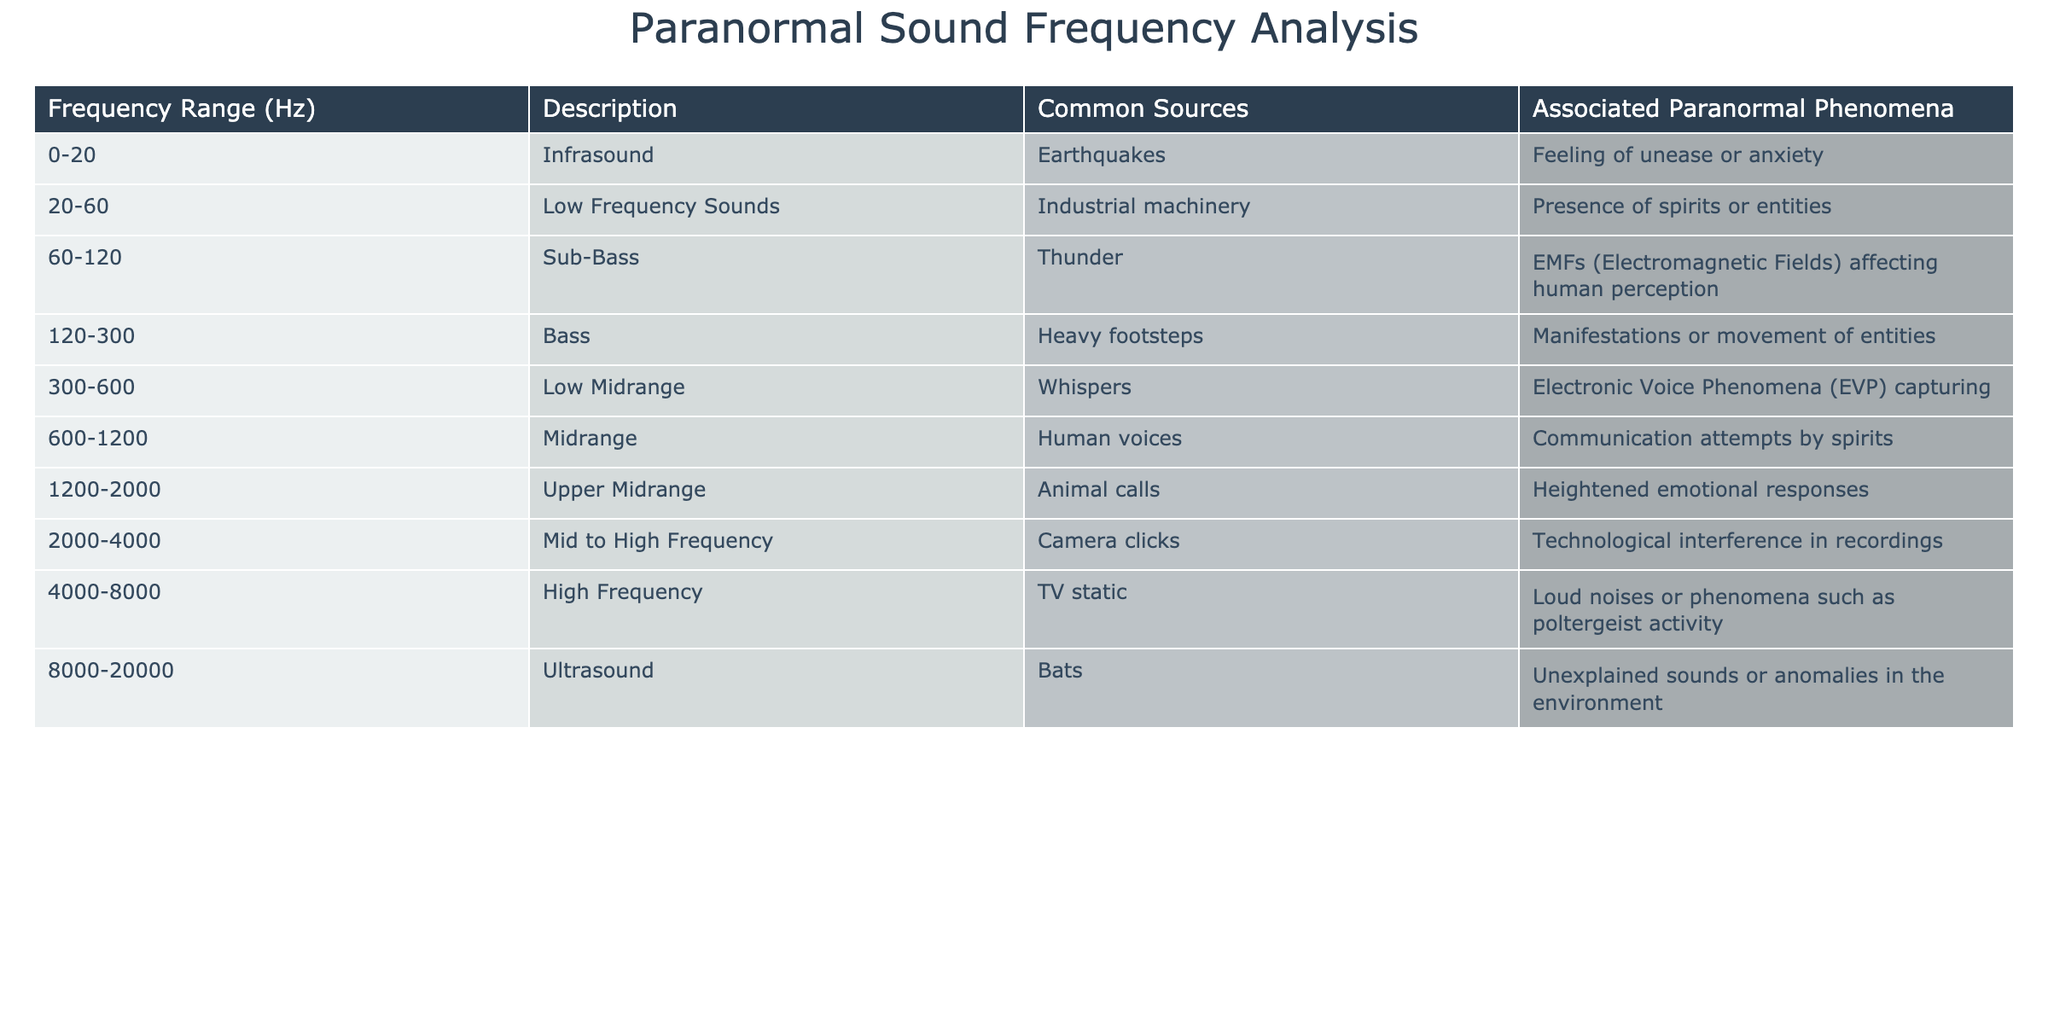What frequency range is associated with whispers? The table clearly shows that whispers fall within the 300-600 Hz frequency range.
Answer: 300-600 Hz Are low frequency sounds more commonly linked to industrial machinery or animal calls? According to the table, low frequency sounds (20-60 Hz) are associated with industrial machinery, while animal calls are linked to the 1200-2000 Hz range. Thus, low frequency sounds are more commonly linked to industrial machinery.
Answer: Industrial machinery What is the highest frequency range in the table, and what is it associated with? The highest frequency range listed is 8000-20000 Hz, which is associated with unexplained sounds or anomalies in the environment.
Answer: 8000-20000 Hz; unexplained sounds or anomalies Are there more frequency ranges associated with EVPs or with technological interference in recordings? The table indicates that EVPs are covered in the 300-600 Hz range, while technological interference is mentioned in the 2000-4000 Hz range. Therefore, there is one range for EVPs and one for technological interference. Hence, they are equal.
Answer: No, they are equal What is the difference in frequency range between heavy footsteps and human voices? Heavy footsteps are found in the 120-300 Hz range and human voices are in the 600-1200 Hz range. To find the difference, we take the ranges: (600 - 120) and (1200 - 300) = 480 Hz for the difference in overlap.
Answer: 480 Hz 